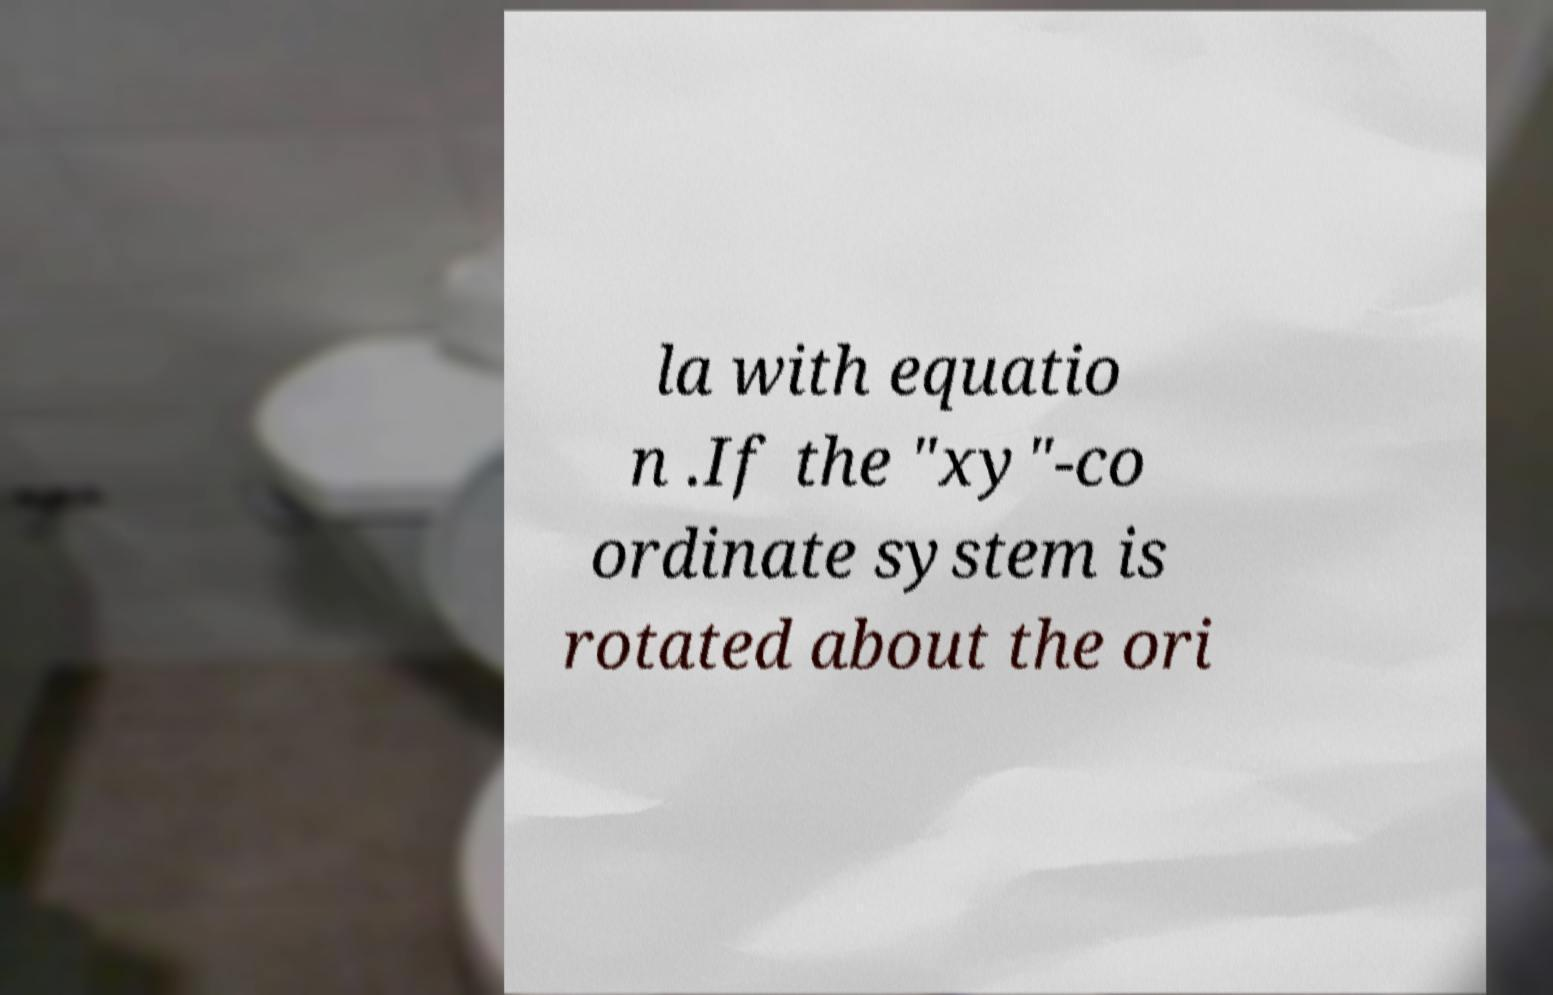There's text embedded in this image that I need extracted. Can you transcribe it verbatim? la with equatio n .If the "xy"-co ordinate system is rotated about the ori 